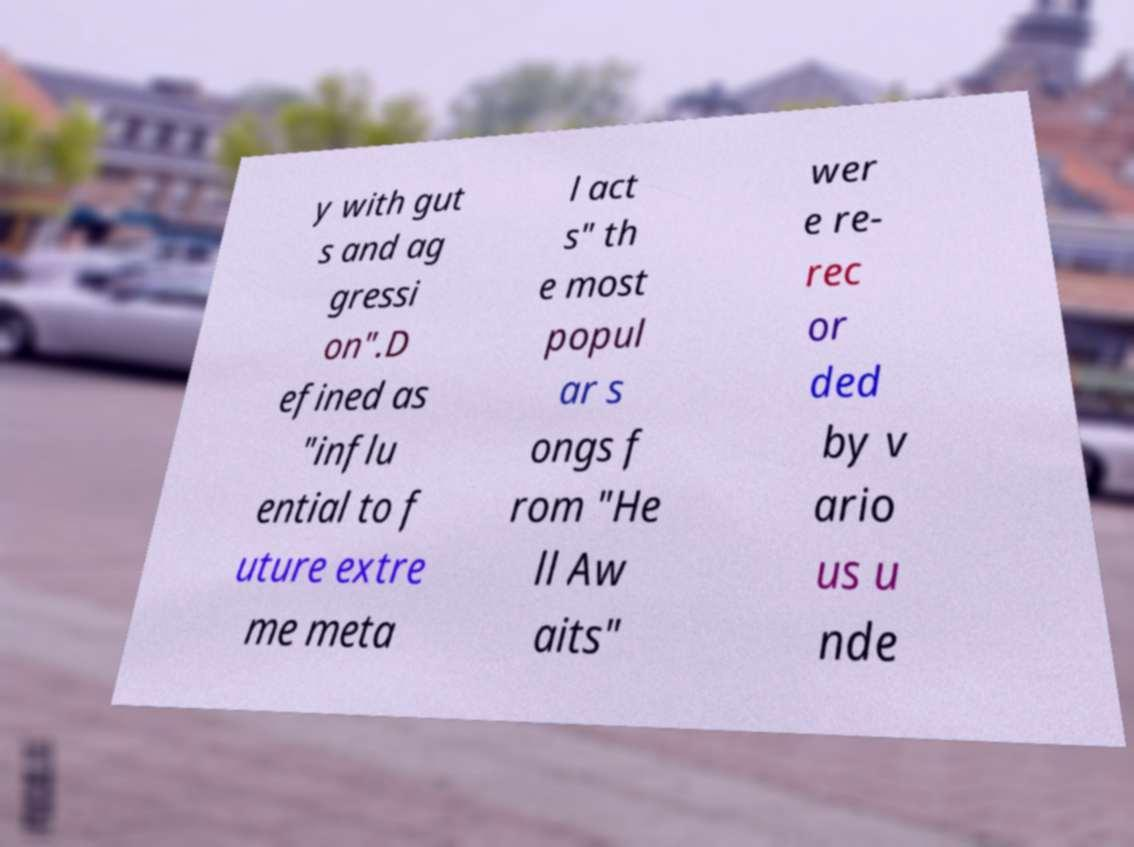Could you extract and type out the text from this image? y with gut s and ag gressi on".D efined as "influ ential to f uture extre me meta l act s" th e most popul ar s ongs f rom "He ll Aw aits" wer e re- rec or ded by v ario us u nde 